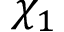<formula> <loc_0><loc_0><loc_500><loc_500>\chi _ { 1 }</formula> 